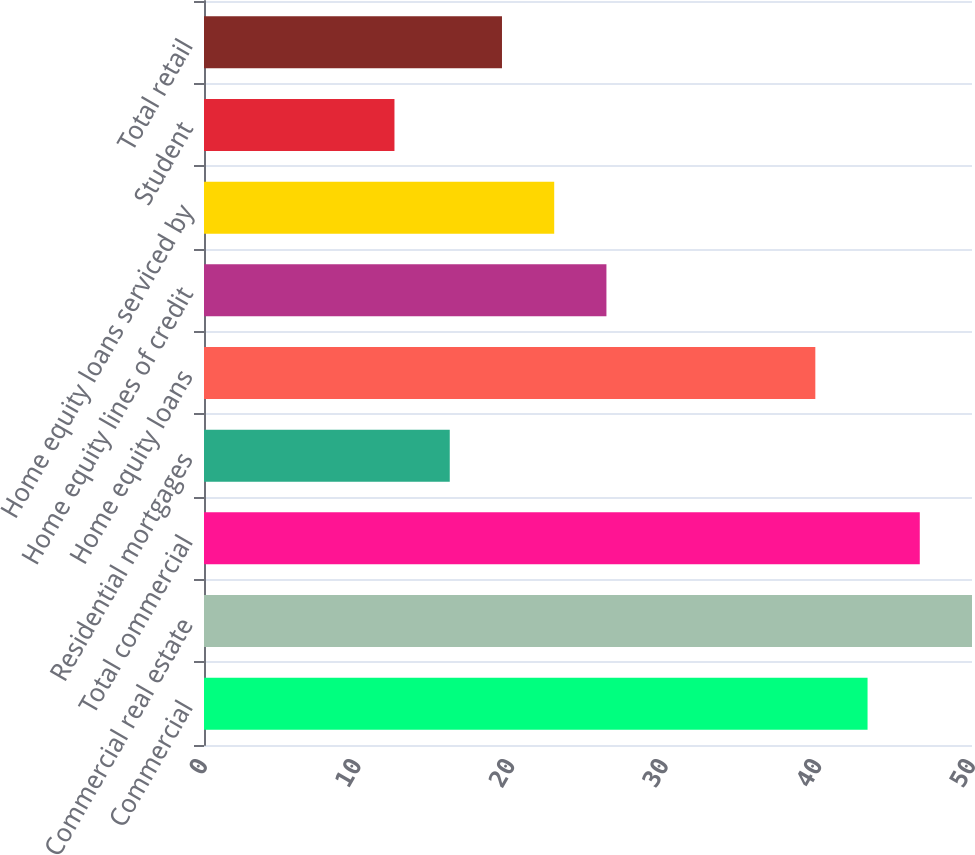Convert chart to OTSL. <chart><loc_0><loc_0><loc_500><loc_500><bar_chart><fcel>Commercial<fcel>Commercial real estate<fcel>Total commercial<fcel>Residential mortgages<fcel>Home equity loans<fcel>Home equity lines of credit<fcel>Home equity loans serviced by<fcel>Student<fcel>Total retail<nl><fcel>43.2<fcel>50<fcel>46.6<fcel>16<fcel>39.8<fcel>26.2<fcel>22.8<fcel>12.4<fcel>19.4<nl></chart> 